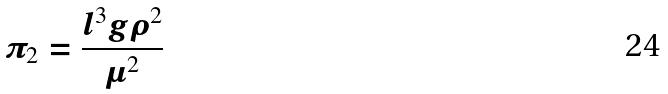Convert formula to latex. <formula><loc_0><loc_0><loc_500><loc_500>\pi _ { 2 } = \frac { l ^ { 3 } g \rho ^ { 2 } } { \mu ^ { 2 } }</formula> 